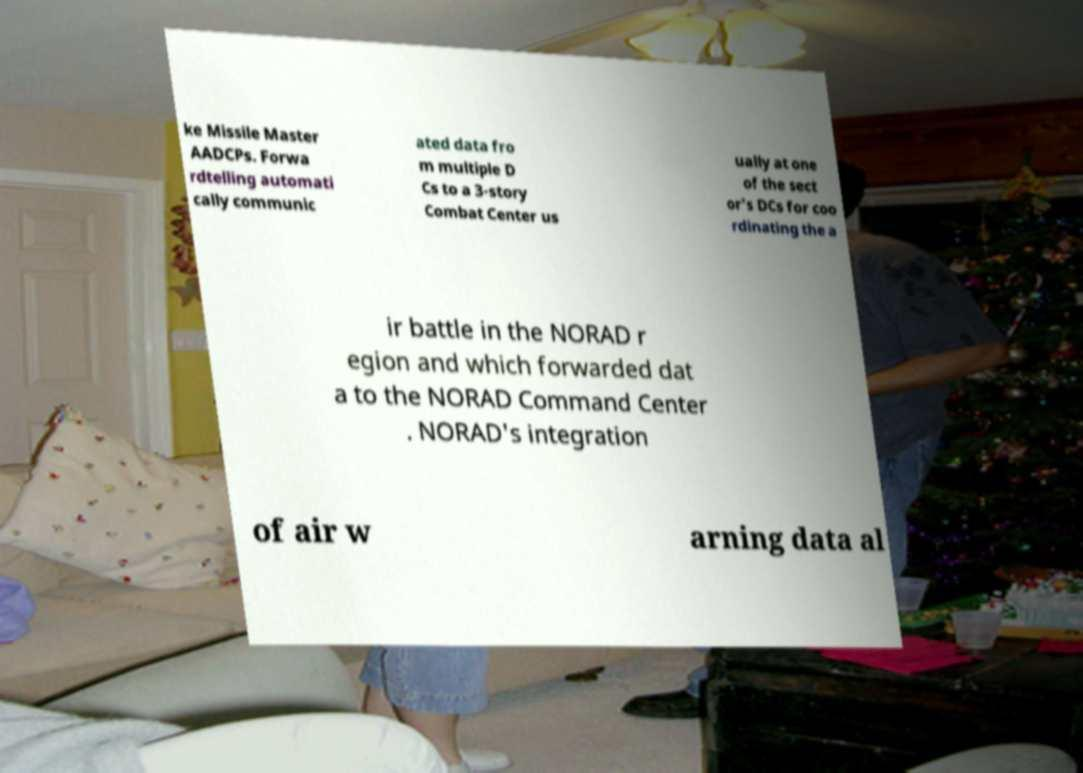I need the written content from this picture converted into text. Can you do that? ke Missile Master AADCPs. Forwa rdtelling automati cally communic ated data fro m multiple D Cs to a 3-story Combat Center us ually at one of the sect or's DCs for coo rdinating the a ir battle in the NORAD r egion and which forwarded dat a to the NORAD Command Center . NORAD's integration of air w arning data al 